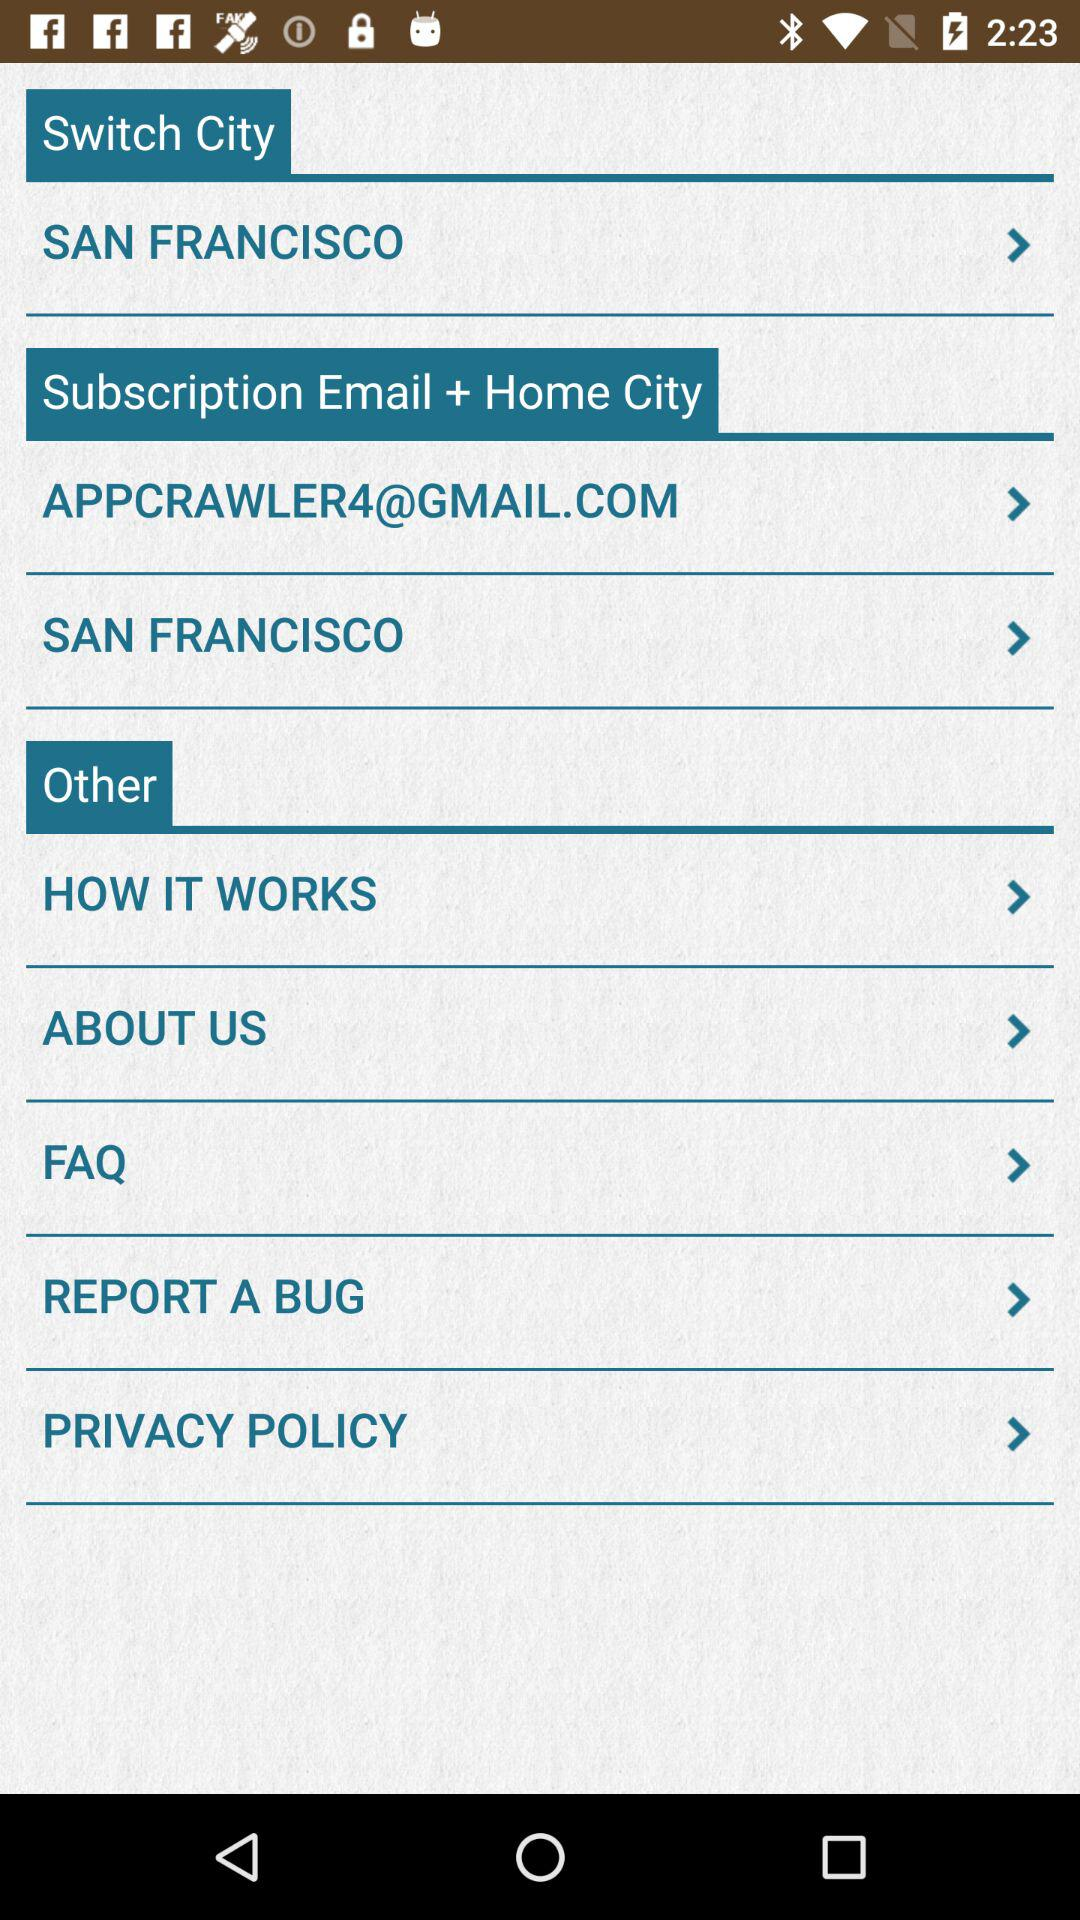What is the name of the city in "Switch City"? The name of the city is San Francisco. 